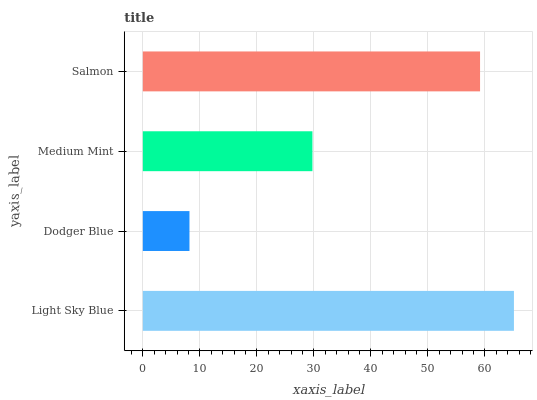Is Dodger Blue the minimum?
Answer yes or no. Yes. Is Light Sky Blue the maximum?
Answer yes or no. Yes. Is Medium Mint the minimum?
Answer yes or no. No. Is Medium Mint the maximum?
Answer yes or no. No. Is Medium Mint greater than Dodger Blue?
Answer yes or no. Yes. Is Dodger Blue less than Medium Mint?
Answer yes or no. Yes. Is Dodger Blue greater than Medium Mint?
Answer yes or no. No. Is Medium Mint less than Dodger Blue?
Answer yes or no. No. Is Salmon the high median?
Answer yes or no. Yes. Is Medium Mint the low median?
Answer yes or no. Yes. Is Dodger Blue the high median?
Answer yes or no. No. Is Light Sky Blue the low median?
Answer yes or no. No. 